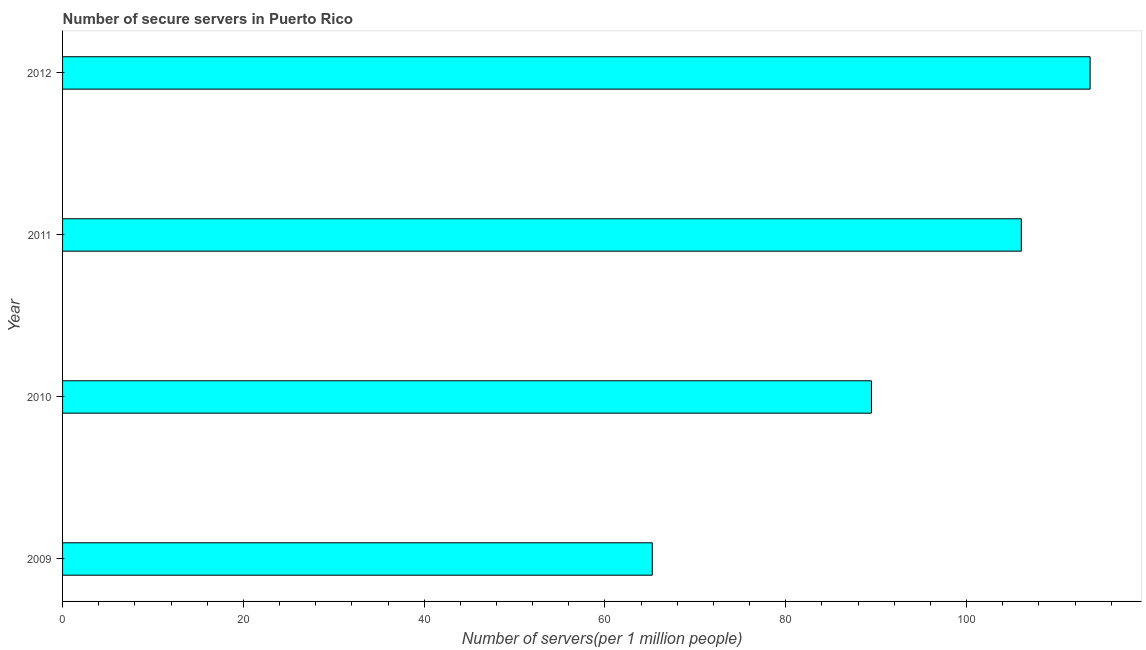Does the graph contain any zero values?
Offer a terse response. No. Does the graph contain grids?
Your answer should be compact. No. What is the title of the graph?
Provide a short and direct response. Number of secure servers in Puerto Rico. What is the label or title of the X-axis?
Provide a succinct answer. Number of servers(per 1 million people). What is the number of secure internet servers in 2011?
Your answer should be very brief. 106.05. Across all years, what is the maximum number of secure internet servers?
Provide a short and direct response. 113.67. Across all years, what is the minimum number of secure internet servers?
Your answer should be compact. 65.23. What is the sum of the number of secure internet servers?
Ensure brevity in your answer.  374.43. What is the difference between the number of secure internet servers in 2010 and 2012?
Offer a very short reply. -24.19. What is the average number of secure internet servers per year?
Provide a short and direct response. 93.61. What is the median number of secure internet servers?
Offer a very short reply. 97.77. What is the ratio of the number of secure internet servers in 2009 to that in 2012?
Your response must be concise. 0.57. What is the difference between the highest and the second highest number of secure internet servers?
Make the answer very short. 7.61. Is the sum of the number of secure internet servers in 2009 and 2011 greater than the maximum number of secure internet servers across all years?
Give a very brief answer. Yes. What is the difference between the highest and the lowest number of secure internet servers?
Your response must be concise. 48.43. How many bars are there?
Give a very brief answer. 4. Are the values on the major ticks of X-axis written in scientific E-notation?
Offer a very short reply. No. What is the Number of servers(per 1 million people) in 2009?
Provide a short and direct response. 65.23. What is the Number of servers(per 1 million people) in 2010?
Provide a succinct answer. 89.48. What is the Number of servers(per 1 million people) of 2011?
Keep it short and to the point. 106.05. What is the Number of servers(per 1 million people) of 2012?
Your response must be concise. 113.67. What is the difference between the Number of servers(per 1 million people) in 2009 and 2010?
Ensure brevity in your answer.  -24.25. What is the difference between the Number of servers(per 1 million people) in 2009 and 2011?
Give a very brief answer. -40.82. What is the difference between the Number of servers(per 1 million people) in 2009 and 2012?
Offer a terse response. -48.43. What is the difference between the Number of servers(per 1 million people) in 2010 and 2011?
Ensure brevity in your answer.  -16.58. What is the difference between the Number of servers(per 1 million people) in 2010 and 2012?
Keep it short and to the point. -24.19. What is the difference between the Number of servers(per 1 million people) in 2011 and 2012?
Offer a very short reply. -7.61. What is the ratio of the Number of servers(per 1 million people) in 2009 to that in 2010?
Offer a terse response. 0.73. What is the ratio of the Number of servers(per 1 million people) in 2009 to that in 2011?
Give a very brief answer. 0.61. What is the ratio of the Number of servers(per 1 million people) in 2009 to that in 2012?
Your answer should be very brief. 0.57. What is the ratio of the Number of servers(per 1 million people) in 2010 to that in 2011?
Your answer should be compact. 0.84. What is the ratio of the Number of servers(per 1 million people) in 2010 to that in 2012?
Your answer should be very brief. 0.79. What is the ratio of the Number of servers(per 1 million people) in 2011 to that in 2012?
Keep it short and to the point. 0.93. 